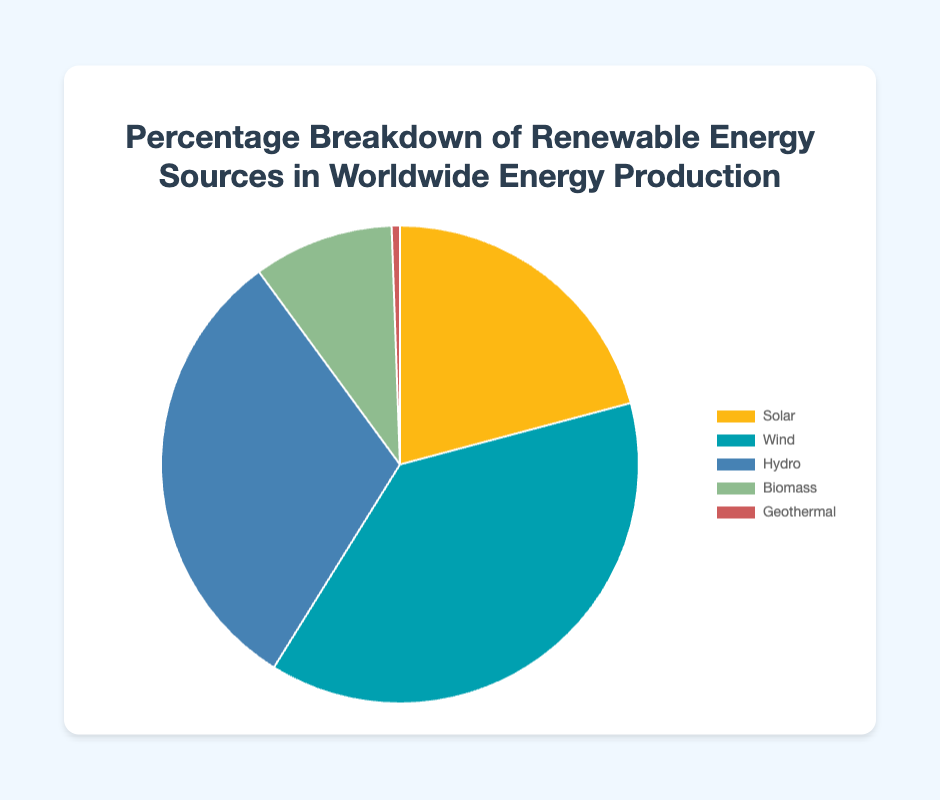What is the percentage of Wind compared to Solar? Wind's percentage is 20.4% and Solar's percentage is 11.2%. Subtract the Solar percentage from the Wind percentage: 20.4% - 11.2% = 9.2%.
Answer: 9.2% What is the combined percentage of Hydro and Biomass? Hydro is 16.7% and Biomass is 5.1%. Adding these together: 16.7% + 5.1% = 21.8%.
Answer: 21.8% Which energy source has the smallest percentage and what is it? Geothermal has the smallest percentage which is 0.3%, as shown in the pie chart.
Answer: Geothermal, 0.3% What is the total percentage of Solar and Wind combined? Solar is 11.2% and Wind is 20.4%. Adding these together: 11.2% + 20.4% = 31.6%.
Answer: 31.6% Which energy source is represented by the green color? The pie chart shows that Biomass is represented by the green color.
Answer: Biomass What is the ratio of Wind to Hydro energy percentage? Wind has 20.4% and Hydro has 16.7%. The ratio is 20.4 : 16.7. Simplifying this ratio, we get approximately 1.22 : 1.
Answer: 1.22 : 1 How much more is the Wind percentage compared to Geothermal? Wind is 20.4% and Geothermal is 0.3%. Subtract Geothermal from Wind: 20.4% - 0.3% = 20.1%.
Answer: 20.1% What is the difference between the highest and lowest energy percentages? The highest energy percentage is Wind at 20.4%, and the lowest is Geothermal at 0.3%. Subtract the lowest from the highest: 20.4% - 0.3% = 20.1%.
Answer: 20.1% Arrange the energy sources from highest to lowest percentage. The percentages are as follows: Wind (20.4%), Hydro (16.7%), Solar (11.2%), Biomass (5.1%), Geothermal (0.3%).
Answer: Wind, Hydro, Solar, Biomass, Geothermal 